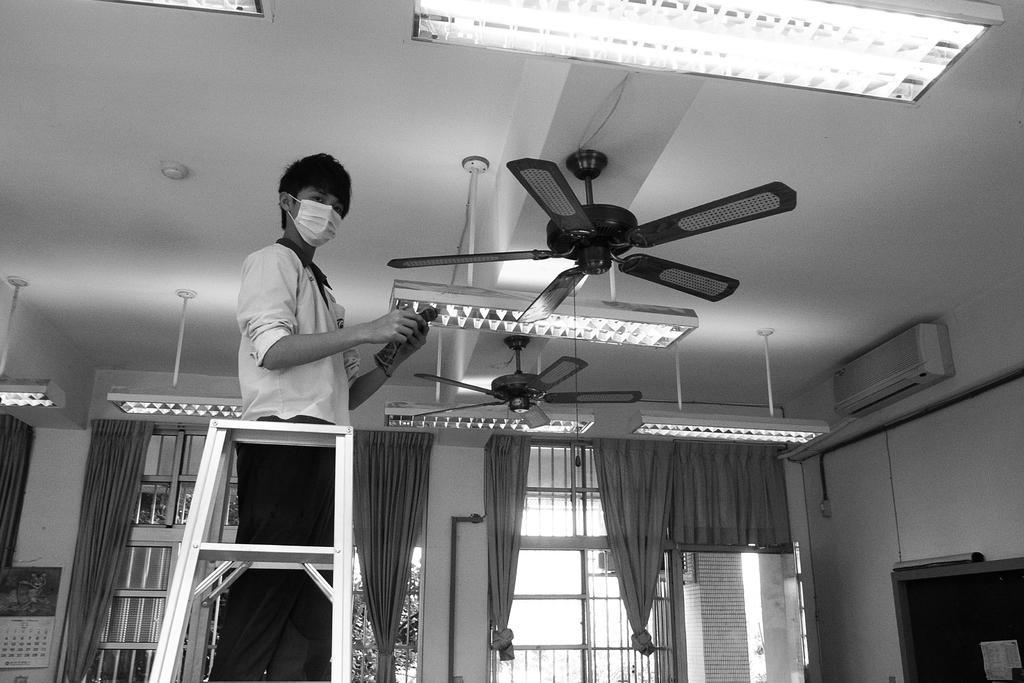In one or two sentences, can you explain what this image depicts? In this image, we can see a person on the ladder wearing clothes and mask. There are fans and lights on the ceiling. There is an AC on the wall. There are curtains on the window. 